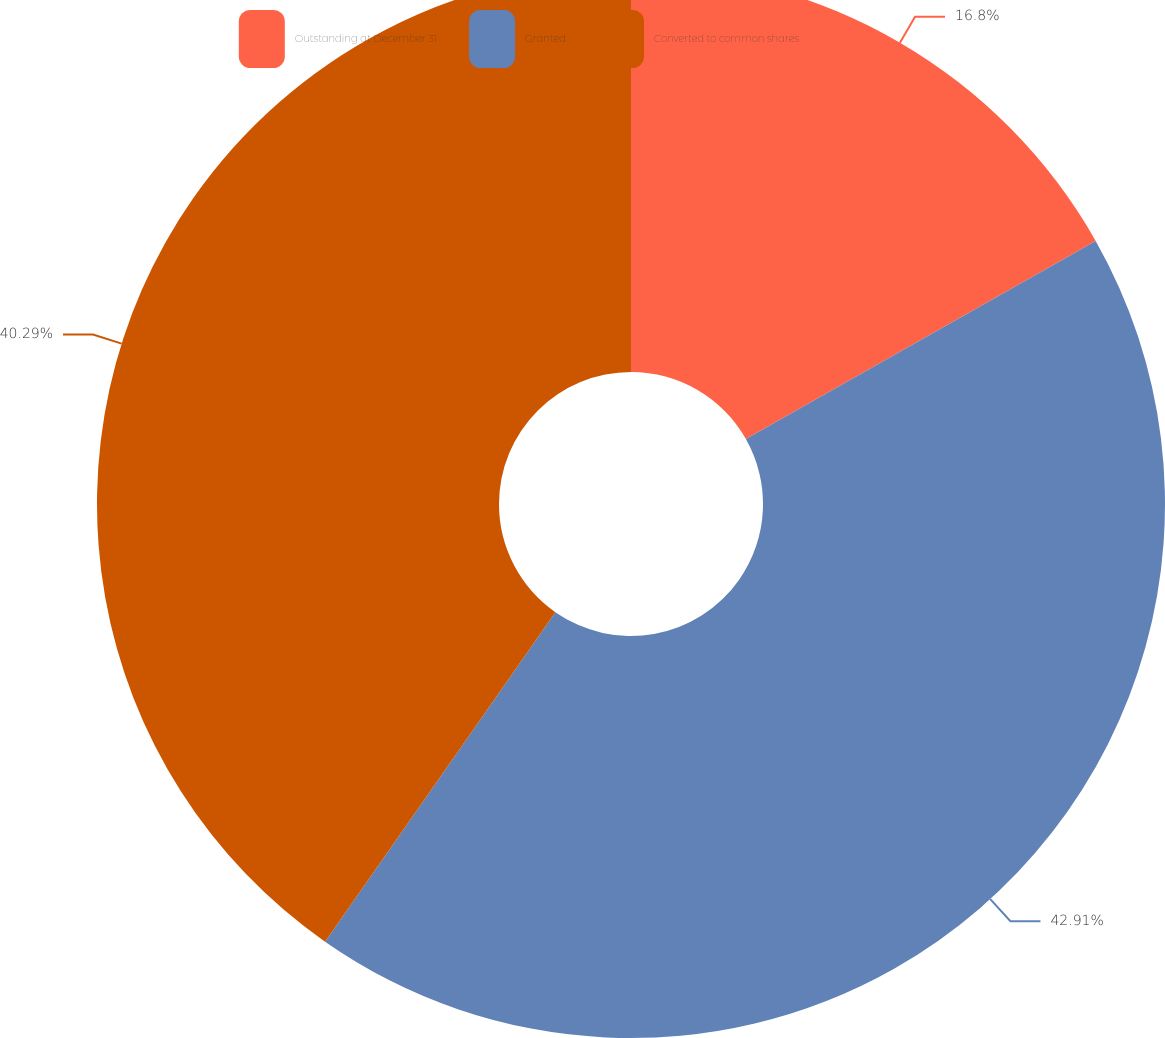Convert chart. <chart><loc_0><loc_0><loc_500><loc_500><pie_chart><fcel>Outstanding at December 31<fcel>Granted<fcel>Converted to common shares<nl><fcel>16.8%<fcel>42.91%<fcel>40.29%<nl></chart> 